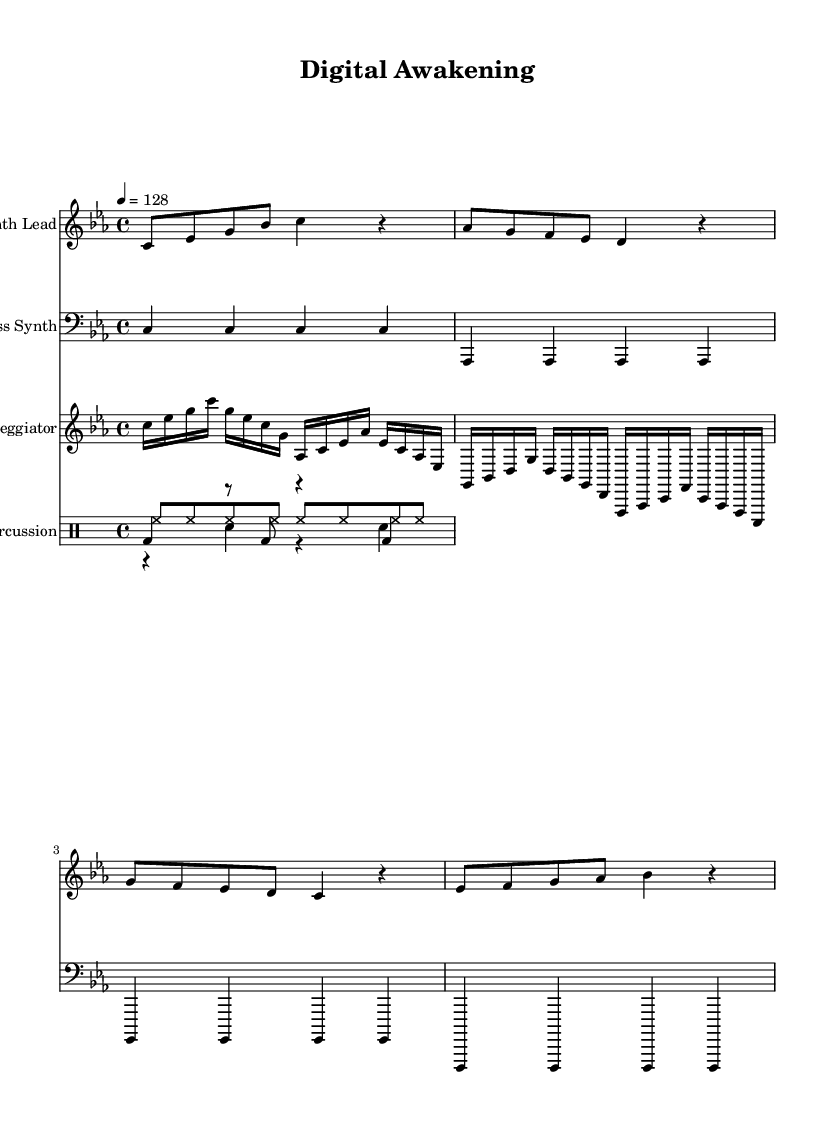What is the key signature of this music? The key signature is C minor, which has three flats: B flat, E flat, and A flat. This can be identified by looking at the beginning of the staff where the key signature is indicated.
Answer: C minor What is the time signature of this music? The time signature is 4/4, which indicates that there are four beats in each measure and a quarter note receives one beat. This can be inferred by observing the numbers at the beginning of the staff.
Answer: 4/4 What is the tempo of this piece? The tempo is set at quarter note equals 128 beats per minute, indicated by the tempo marking at the beginning of the score. This number provides insight into the speed at which the music is to be played.
Answer: 128 How many measures are in the synth lead section? The synth lead section consists of four measures, which can be counted by observing the vertical lines that separate each measure in the sheet music.
Answer: 4 Which instrument has the highest pitch? The synth lead has the highest pitch, as it is notated in the treble clef and generally plays higher notes than the bass synth and other instruments listed. This can be confirmed by comparing the pitch ranges of the parts written on the staff.
Answer: Synth Lead What rhythmic pattern is used for the kick drum? The kick drum uses a pattern consisting of a primary beat followed by rests, and two additional beats: one eighth note rest, one eighth note kick, and then a quarter note kick in a repeating cycle. This pattern can be observed in the drum mode section specifically for the kick drum.
Answer: Kick drum pattern What type of synthesizer sound is represented by the bass synth? The bass synth produces a deep, resonant synth sound, often characteristic of electronic dance music. It is indicated by the staff labeled "Bass Synth," which usually serves as the foundation and harmonic support in the track.
Answer: Deep synth sound 